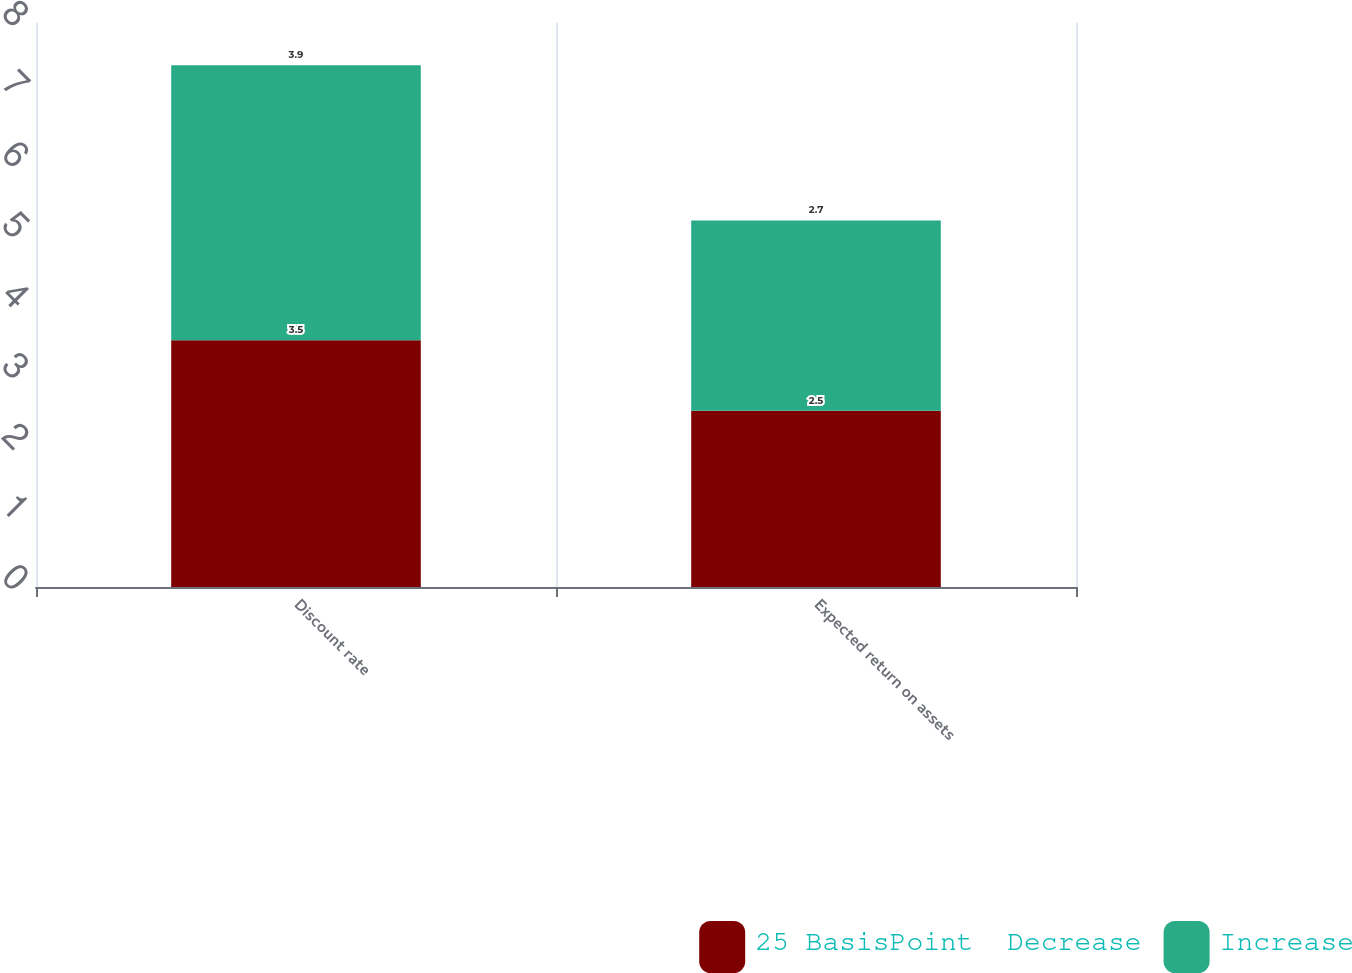Convert chart to OTSL. <chart><loc_0><loc_0><loc_500><loc_500><stacked_bar_chart><ecel><fcel>Discount rate<fcel>Expected return on assets<nl><fcel>25 BasisPoint  Decrease<fcel>3.5<fcel>2.5<nl><fcel>Increase<fcel>3.9<fcel>2.7<nl></chart> 